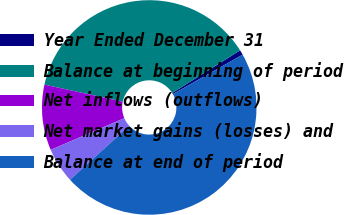Convert chart. <chart><loc_0><loc_0><loc_500><loc_500><pie_chart><fcel>Year Ended December 31<fcel>Balance at beginning of period<fcel>Net inflows (outflows)<fcel>Net market gains (losses) and<fcel>Balance at end of period<nl><fcel>0.74%<fcel>37.66%<fcel>9.88%<fcel>5.31%<fcel>46.41%<nl></chart> 